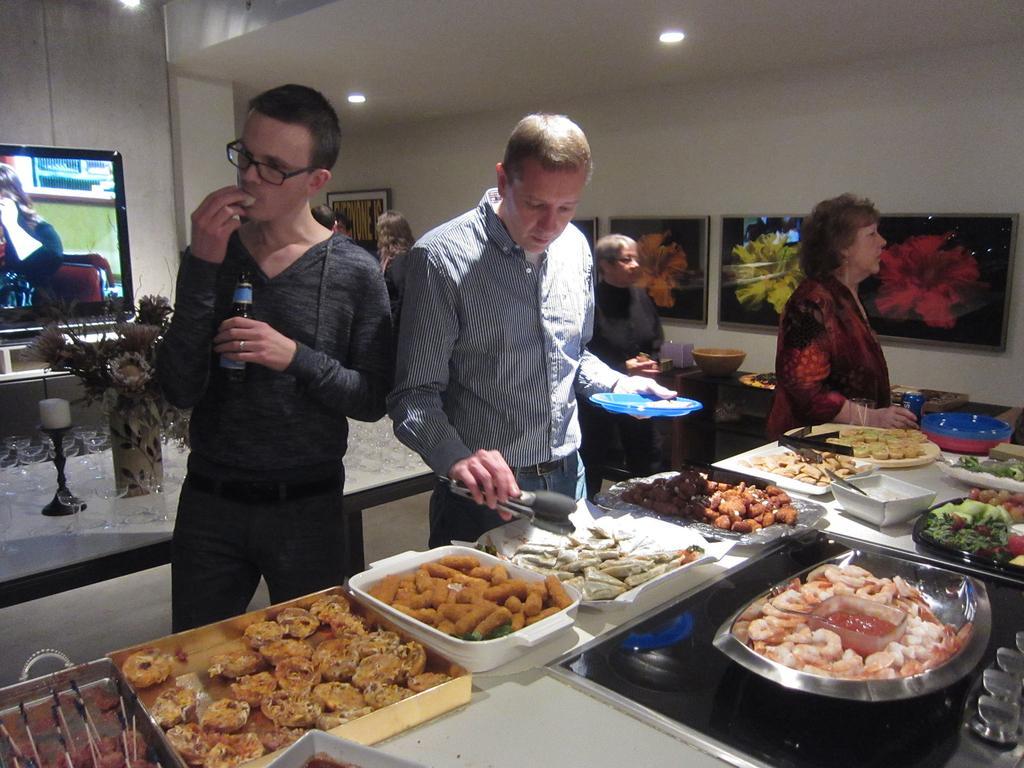Describe this image in one or two sentences. In the left side there is a tv. On the left top right there is a light in the middle there is a table on the table there is a house plant and to the left there is a person he is wearing a black jerking and he is catching a bottle in his hand and he is eating food. To the right there is another person he is wearing a shirt and a trouser he is holding a plate with some food and in the right side there is a big table on the table there are many trays and food items on that there is a bowl and there is a woman in the right she is wearing a dress and to the right there is a photo frame. 